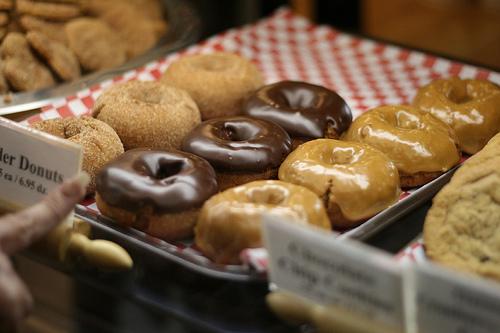Is the picture clear?
Quick response, please. Yes. What type of food is to the right of the donuts?
Answer briefly. Cookies. What meal are these food items for?
Write a very short answer. Breakfast. Which one of the donuts looks more delicious?
Answer briefly. Chocolate. How many chocolate donuts are there?
Keep it brief. 3. Is there anything on top of the donuts to the right?
Give a very brief answer. Yes. 